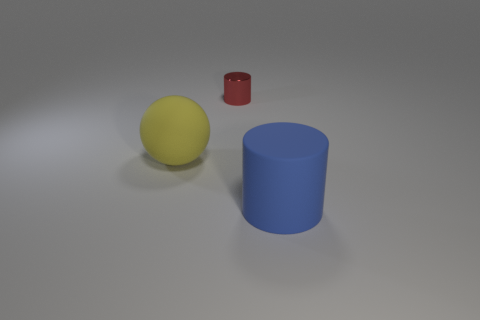Add 2 yellow balls. How many objects exist? 5 Subtract all cylinders. How many objects are left? 1 Subtract 0 gray balls. How many objects are left? 3 Subtract all brown balls. Subtract all purple cylinders. How many balls are left? 1 Subtract all yellow rubber cylinders. Subtract all small red things. How many objects are left? 2 Add 1 blue matte objects. How many blue matte objects are left? 2 Add 3 big yellow objects. How many big yellow objects exist? 4 